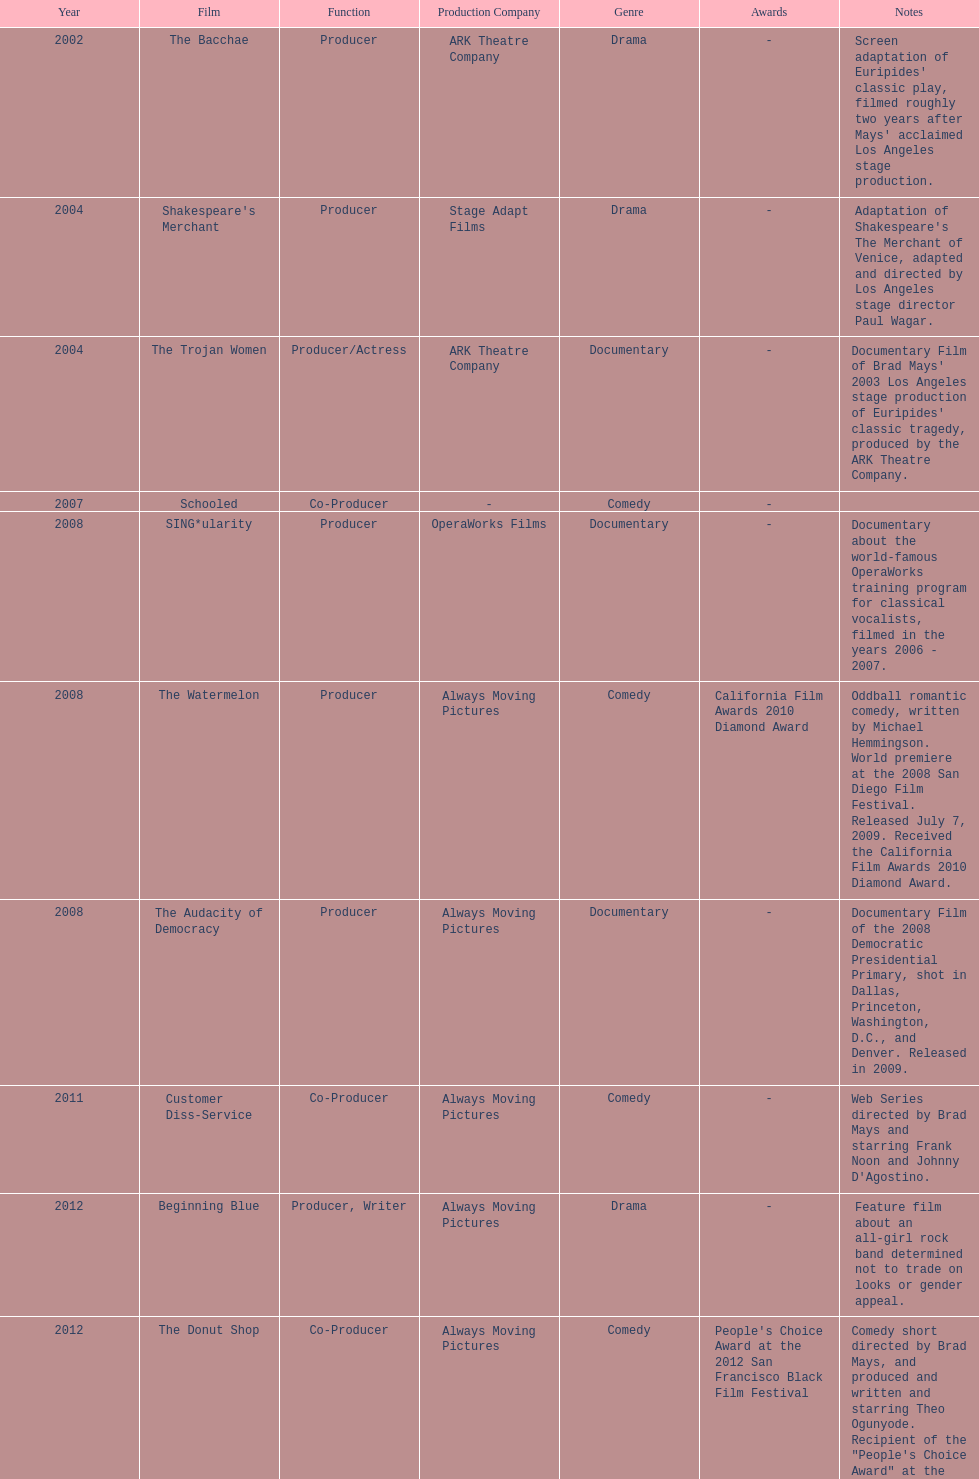What documentary film was produced before the year 2011 but after 2008? The Audacity of Democracy. 